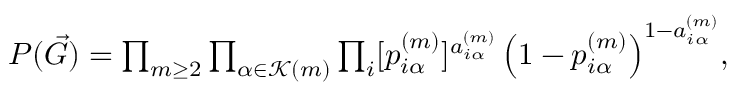Convert formula to latex. <formula><loc_0><loc_0><loc_500><loc_500>\begin{array} { r } { \, P ( \vec { G } ) = \prod _ { m \geq 2 } \prod _ { \alpha \in \mathcal { K } ( m ) } \prod _ { i } [ p _ { i \alpha } ^ { ( m ) } ] ^ { a _ { i \alpha } ^ { ( m ) } } \left ( 1 - p _ { i \alpha } ^ { ( m ) } \right ) ^ { 1 - a _ { i \alpha } ^ { ( m ) } } \, , } \end{array}</formula> 